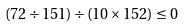Convert formula to latex. <formula><loc_0><loc_0><loc_500><loc_500>( 7 2 \div 1 5 1 ) \div ( 1 0 \times 1 5 2 ) \leq 0</formula> 